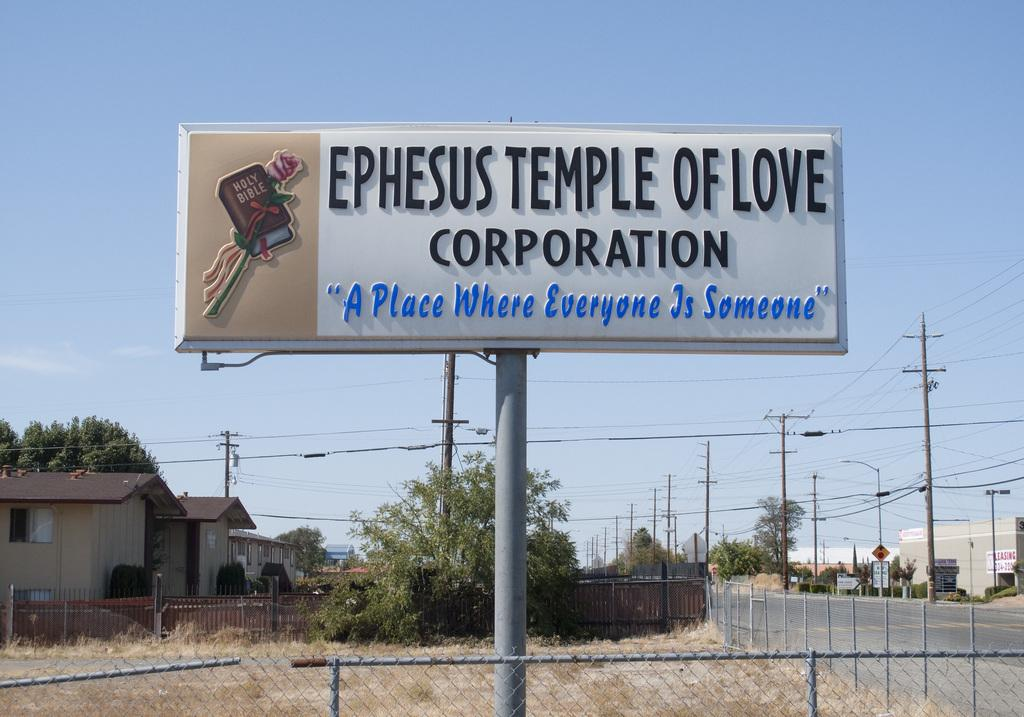<image>
Give a short and clear explanation of the subsequent image. a big public billboard sign stating EPHESUS TEMPLE OF LOVE CORPORATION "A Place Where Everyone Is Someone" with a bible picture. 